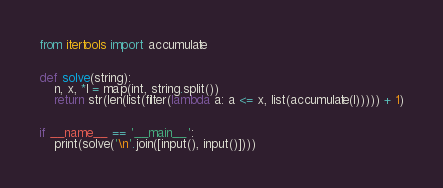<code> <loc_0><loc_0><loc_500><loc_500><_Python_>from itertools import accumulate


def solve(string):
    n, x, *l = map(int, string.split())
    return str(len(list(filter(lambda a: a <= x, list(accumulate(l))))) + 1)


if __name__ == '__main__':
    print(solve('\n'.join([input(), input()])))
</code> 